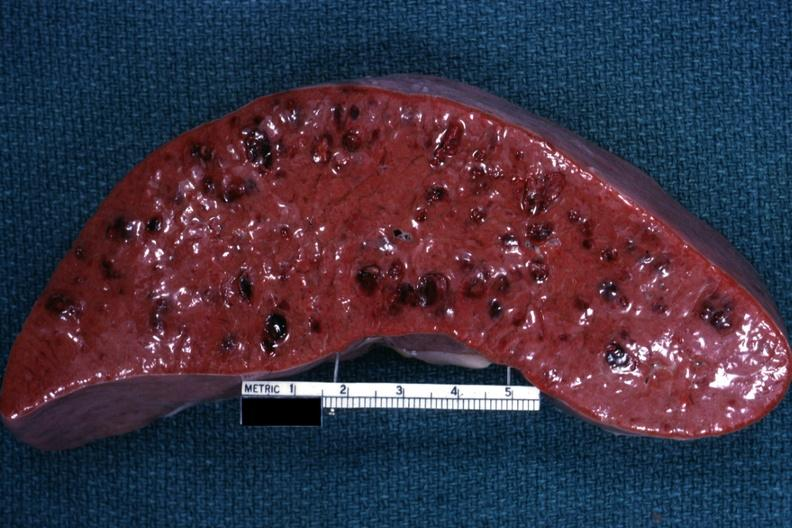s acute myelogenous leukemia present?
Answer the question using a single word or phrase. Yes 